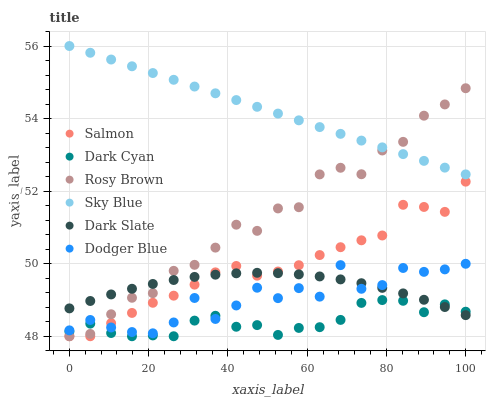Does Dark Cyan have the minimum area under the curve?
Answer yes or no. Yes. Does Sky Blue have the maximum area under the curve?
Answer yes or no. Yes. Does Salmon have the minimum area under the curve?
Answer yes or no. No. Does Salmon have the maximum area under the curve?
Answer yes or no. No. Is Sky Blue the smoothest?
Answer yes or no. Yes. Is Dodger Blue the roughest?
Answer yes or no. Yes. Is Salmon the smoothest?
Answer yes or no. No. Is Salmon the roughest?
Answer yes or no. No. Does Rosy Brown have the lowest value?
Answer yes or no. Yes. Does Dark Slate have the lowest value?
Answer yes or no. No. Does Sky Blue have the highest value?
Answer yes or no. Yes. Does Salmon have the highest value?
Answer yes or no. No. Is Dodger Blue less than Sky Blue?
Answer yes or no. Yes. Is Sky Blue greater than Dodger Blue?
Answer yes or no. Yes. Does Dark Slate intersect Dark Cyan?
Answer yes or no. Yes. Is Dark Slate less than Dark Cyan?
Answer yes or no. No. Is Dark Slate greater than Dark Cyan?
Answer yes or no. No. Does Dodger Blue intersect Sky Blue?
Answer yes or no. No. 